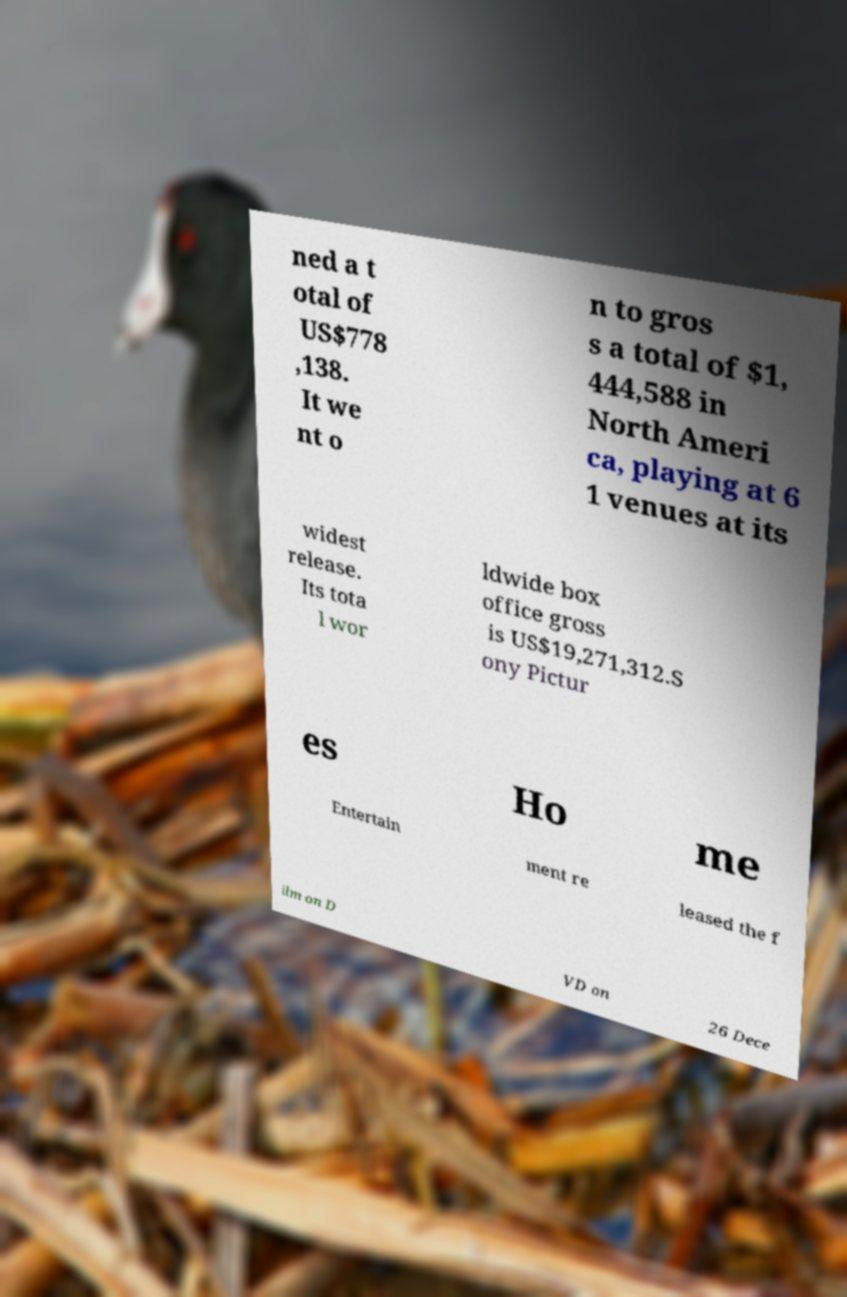Can you read and provide the text displayed in the image?This photo seems to have some interesting text. Can you extract and type it out for me? ned a t otal of US$778 ,138. It we nt o n to gros s a total of $1, 444,588 in North Ameri ca, playing at 6 1 venues at its widest release. Its tota l wor ldwide box office gross is US$19,271,312.S ony Pictur es Ho me Entertain ment re leased the f ilm on D VD on 26 Dece 